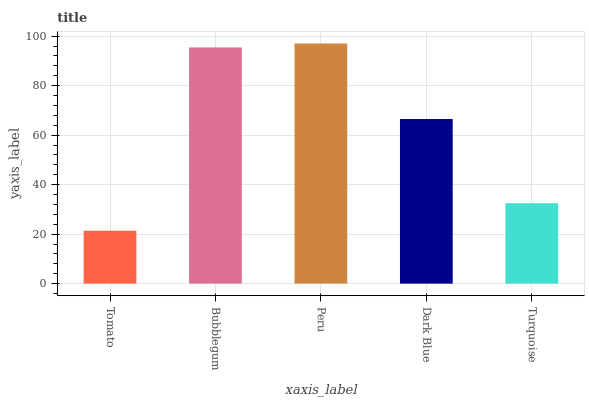Is Bubblegum the minimum?
Answer yes or no. No. Is Bubblegum the maximum?
Answer yes or no. No. Is Bubblegum greater than Tomato?
Answer yes or no. Yes. Is Tomato less than Bubblegum?
Answer yes or no. Yes. Is Tomato greater than Bubblegum?
Answer yes or no. No. Is Bubblegum less than Tomato?
Answer yes or no. No. Is Dark Blue the high median?
Answer yes or no. Yes. Is Dark Blue the low median?
Answer yes or no. Yes. Is Peru the high median?
Answer yes or no. No. Is Turquoise the low median?
Answer yes or no. No. 